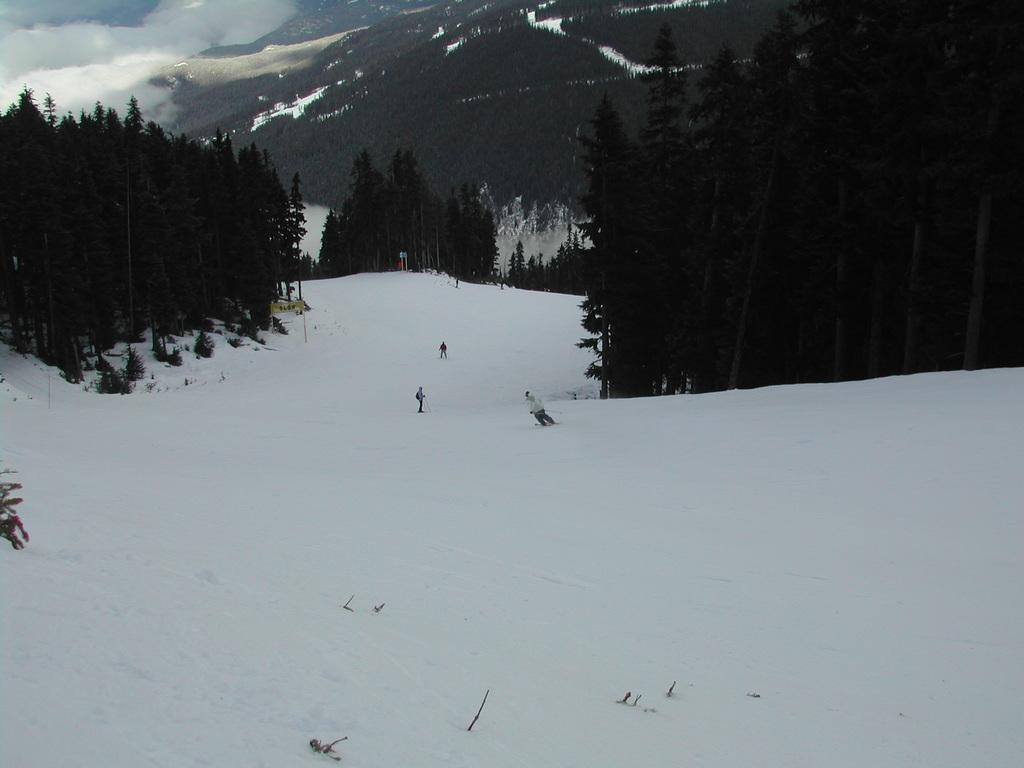What are the persons in the image doing? The persons in the image are skiing. What surface are they skiing on? They are skiing in snow. What can be seen in the middle of the image? There are trees in the middle of the image. What geographical feature is visible at the top of the image? There are mountains at the top of the image. What type of boot can be seen on the person talking in the image? There is no person talking in the image, and no boots are visible. 